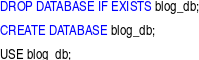<code> <loc_0><loc_0><loc_500><loc_500><_SQL_>DROP DATABASE IF EXISTS blog_db;

CREATE DATABASE blog_db;

USE blog_db;</code> 